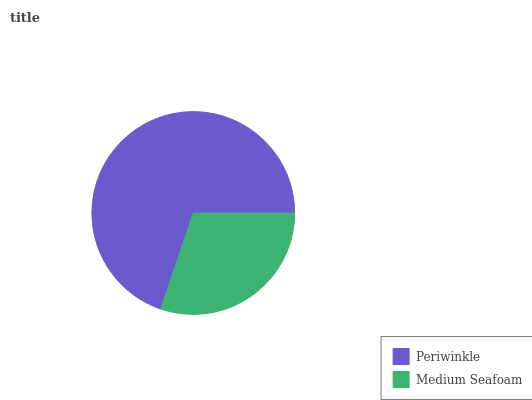Is Medium Seafoam the minimum?
Answer yes or no. Yes. Is Periwinkle the maximum?
Answer yes or no. Yes. Is Medium Seafoam the maximum?
Answer yes or no. No. Is Periwinkle greater than Medium Seafoam?
Answer yes or no. Yes. Is Medium Seafoam less than Periwinkle?
Answer yes or no. Yes. Is Medium Seafoam greater than Periwinkle?
Answer yes or no. No. Is Periwinkle less than Medium Seafoam?
Answer yes or no. No. Is Periwinkle the high median?
Answer yes or no. Yes. Is Medium Seafoam the low median?
Answer yes or no. Yes. Is Medium Seafoam the high median?
Answer yes or no. No. Is Periwinkle the low median?
Answer yes or no. No. 